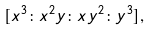Convert formula to latex. <formula><loc_0><loc_0><loc_500><loc_500>[ x ^ { 3 } \colon x ^ { 2 } y \colon x y ^ { 2 } \colon y ^ { 3 } ] ,</formula> 